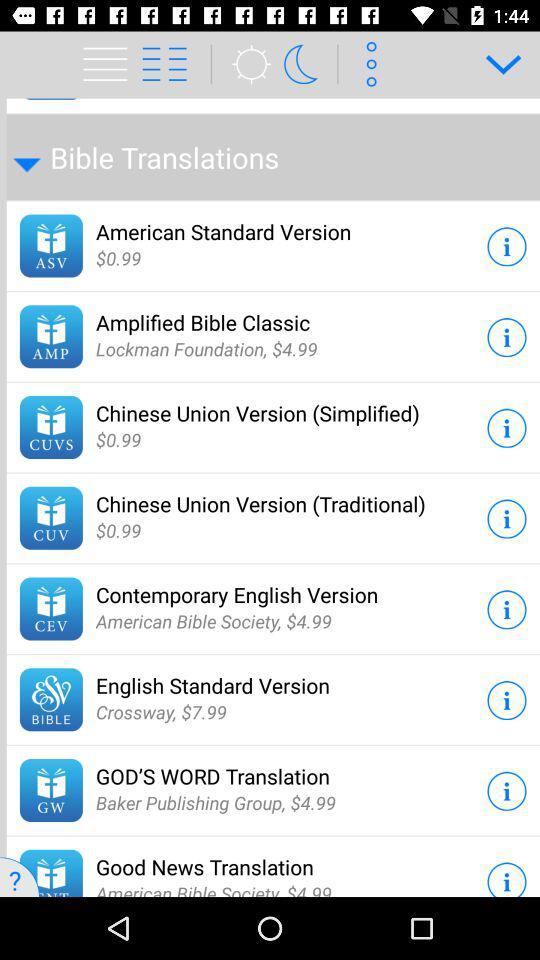What is the price of the English Standard Version Bible translations? The price is $7.99. 